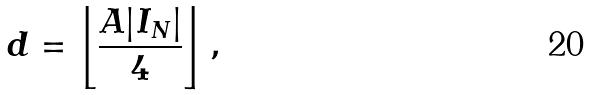<formula> <loc_0><loc_0><loc_500><loc_500>d = \left \lfloor \frac { A | I _ { N } | } { 4 } \right \rfloor ,</formula> 